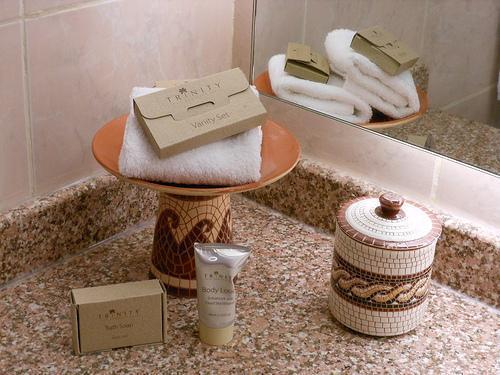How many washcloths are there?
Give a very brief answer. 2. 